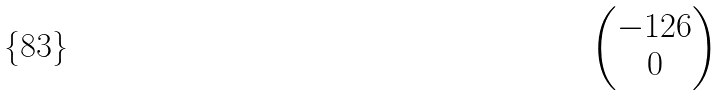<formula> <loc_0><loc_0><loc_500><loc_500>\begin{pmatrix} - 1 2 6 \\ 0 \end{pmatrix}</formula> 